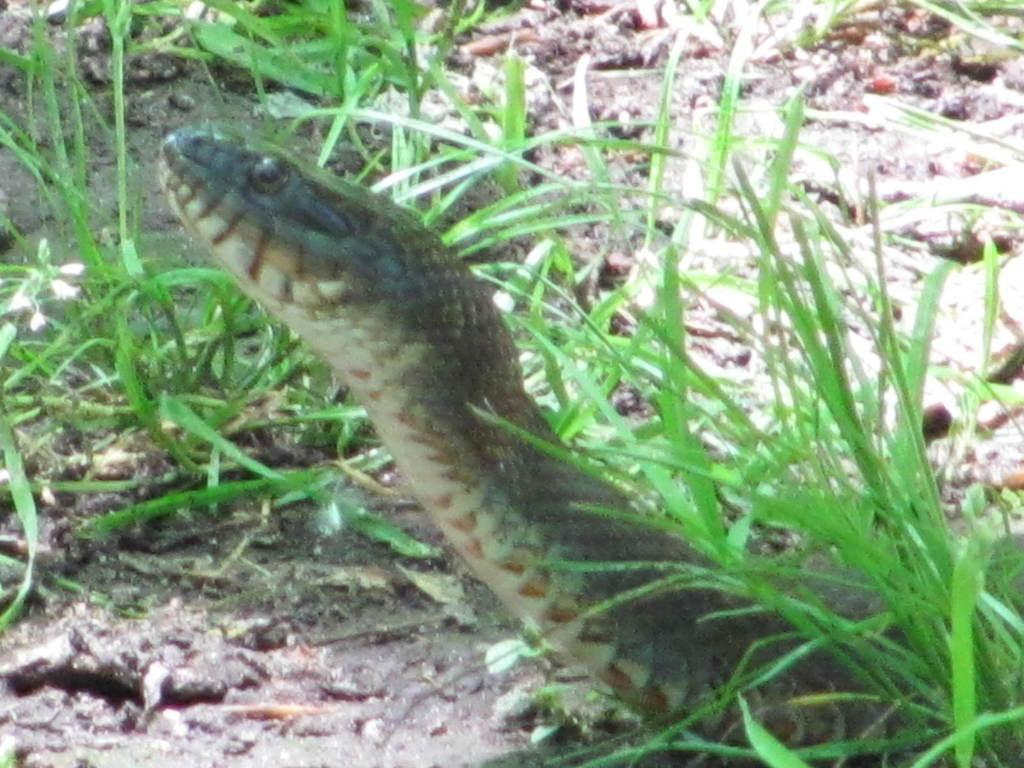What type of animal is in the image? There is a snake in the image. Where is the snake located? The snake is on the ground. What type of vegetation can be seen in the image? There is green grass visible in the image. What type of wrench is the snake using to fix the car in the image? There is no wrench or car present in the image; it features a snake on the ground with green grass. 